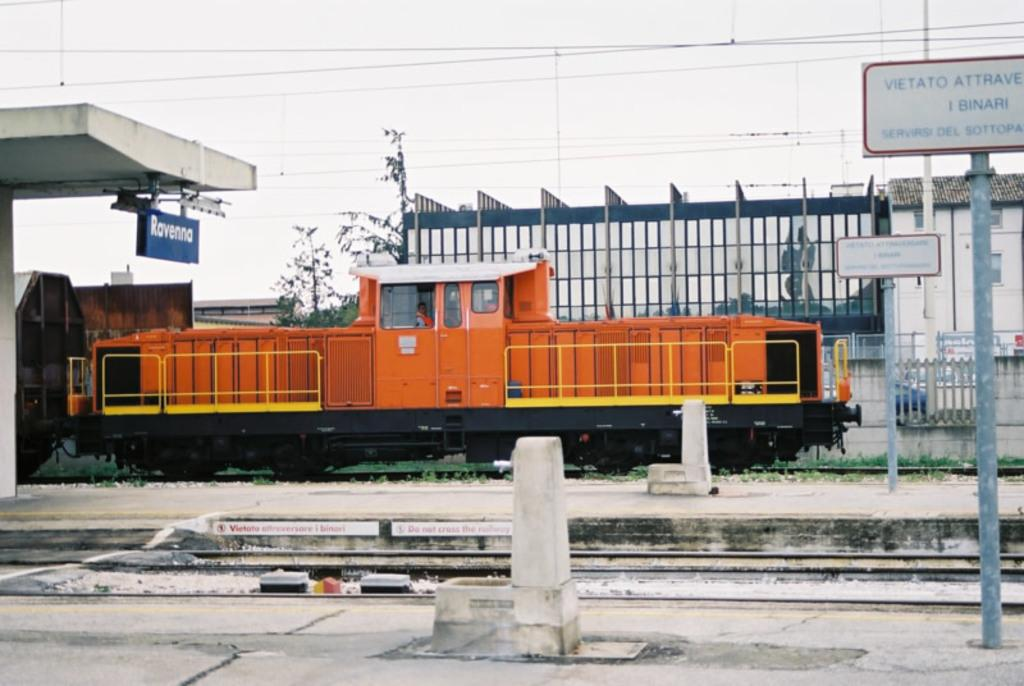<image>
Summarize the visual content of the image. An orange train parked under a sign that says Ravenna. 